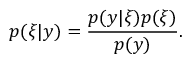Convert formula to latex. <formula><loc_0><loc_0><loc_500><loc_500>p ( \xi | y ) = \frac { p ( y | \xi ) p ( \xi ) } { p ( y ) } .</formula> 